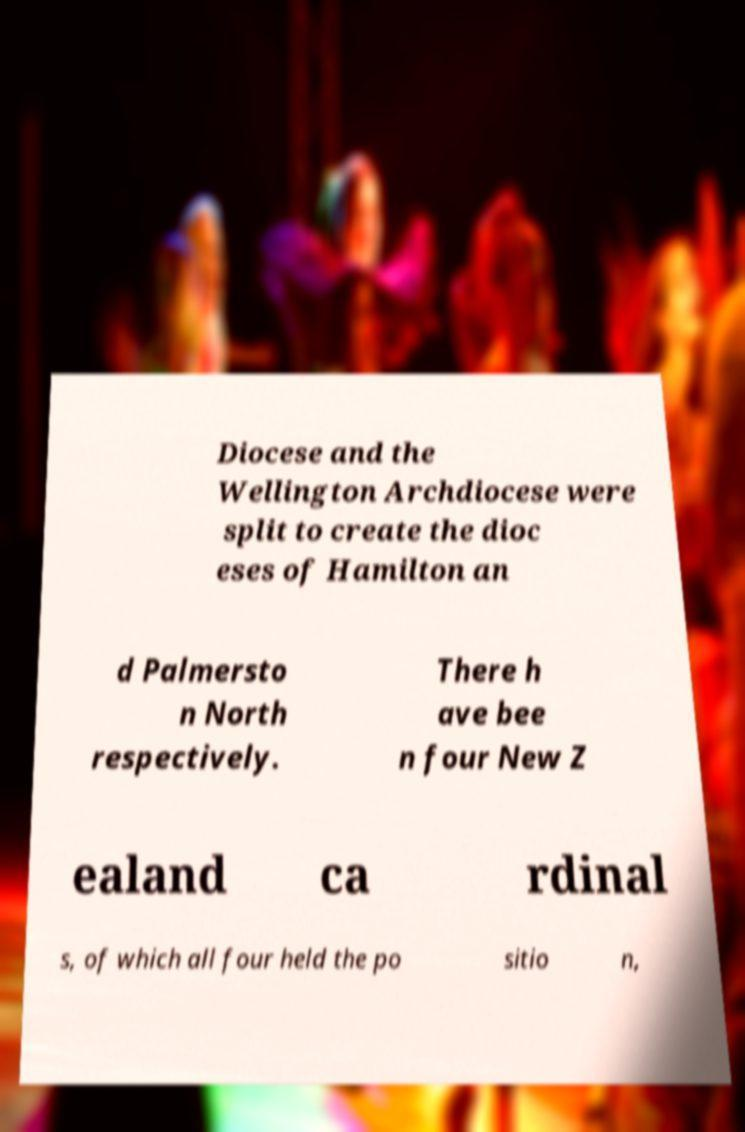What messages or text are displayed in this image? I need them in a readable, typed format. Diocese and the Wellington Archdiocese were split to create the dioc eses of Hamilton an d Palmersto n North respectively. There h ave bee n four New Z ealand ca rdinal s, of which all four held the po sitio n, 